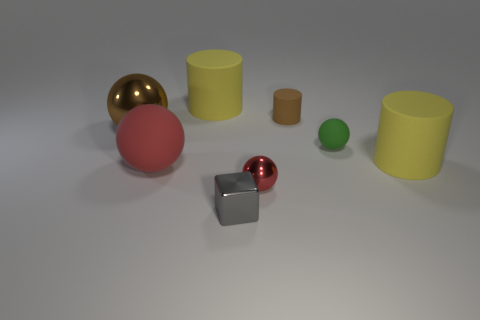Do the yellow thing that is on the right side of the gray shiny object and the brown thing that is to the right of the brown ball have the same size?
Give a very brief answer. No. What material is the sphere that is behind the large red thing and left of the small green rubber thing?
Keep it short and to the point. Metal. Are there any other things that are the same color as the big metallic object?
Provide a short and direct response. Yes. Are there fewer red rubber balls that are behind the big brown shiny thing than brown matte cylinders?
Keep it short and to the point. Yes. Are there more green rubber objects than brown objects?
Your answer should be very brief. No. Are there any small spheres that are behind the big yellow rubber cylinder that is on the left side of the small metal thing behind the cube?
Keep it short and to the point. No. What number of other objects are the same size as the metal block?
Provide a succinct answer. 3. There is a brown cylinder; are there any small rubber objects in front of it?
Make the answer very short. Yes. There is a small rubber sphere; does it have the same color as the cylinder that is on the right side of the small rubber cylinder?
Make the answer very short. No. There is a large cylinder that is right of the big yellow rubber cylinder behind the brown thing to the right of the tiny gray thing; what is its color?
Offer a terse response. Yellow. 